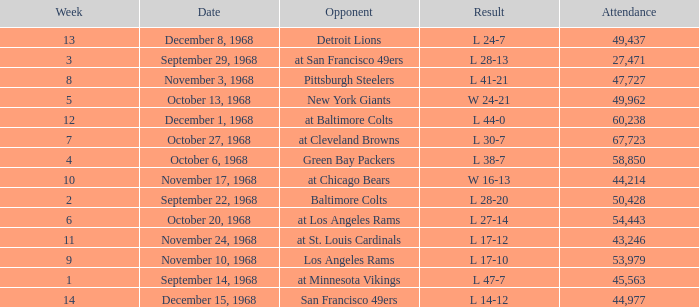Which Attendance has a Date of september 29, 1968, and a Week smaller than 3? None. 